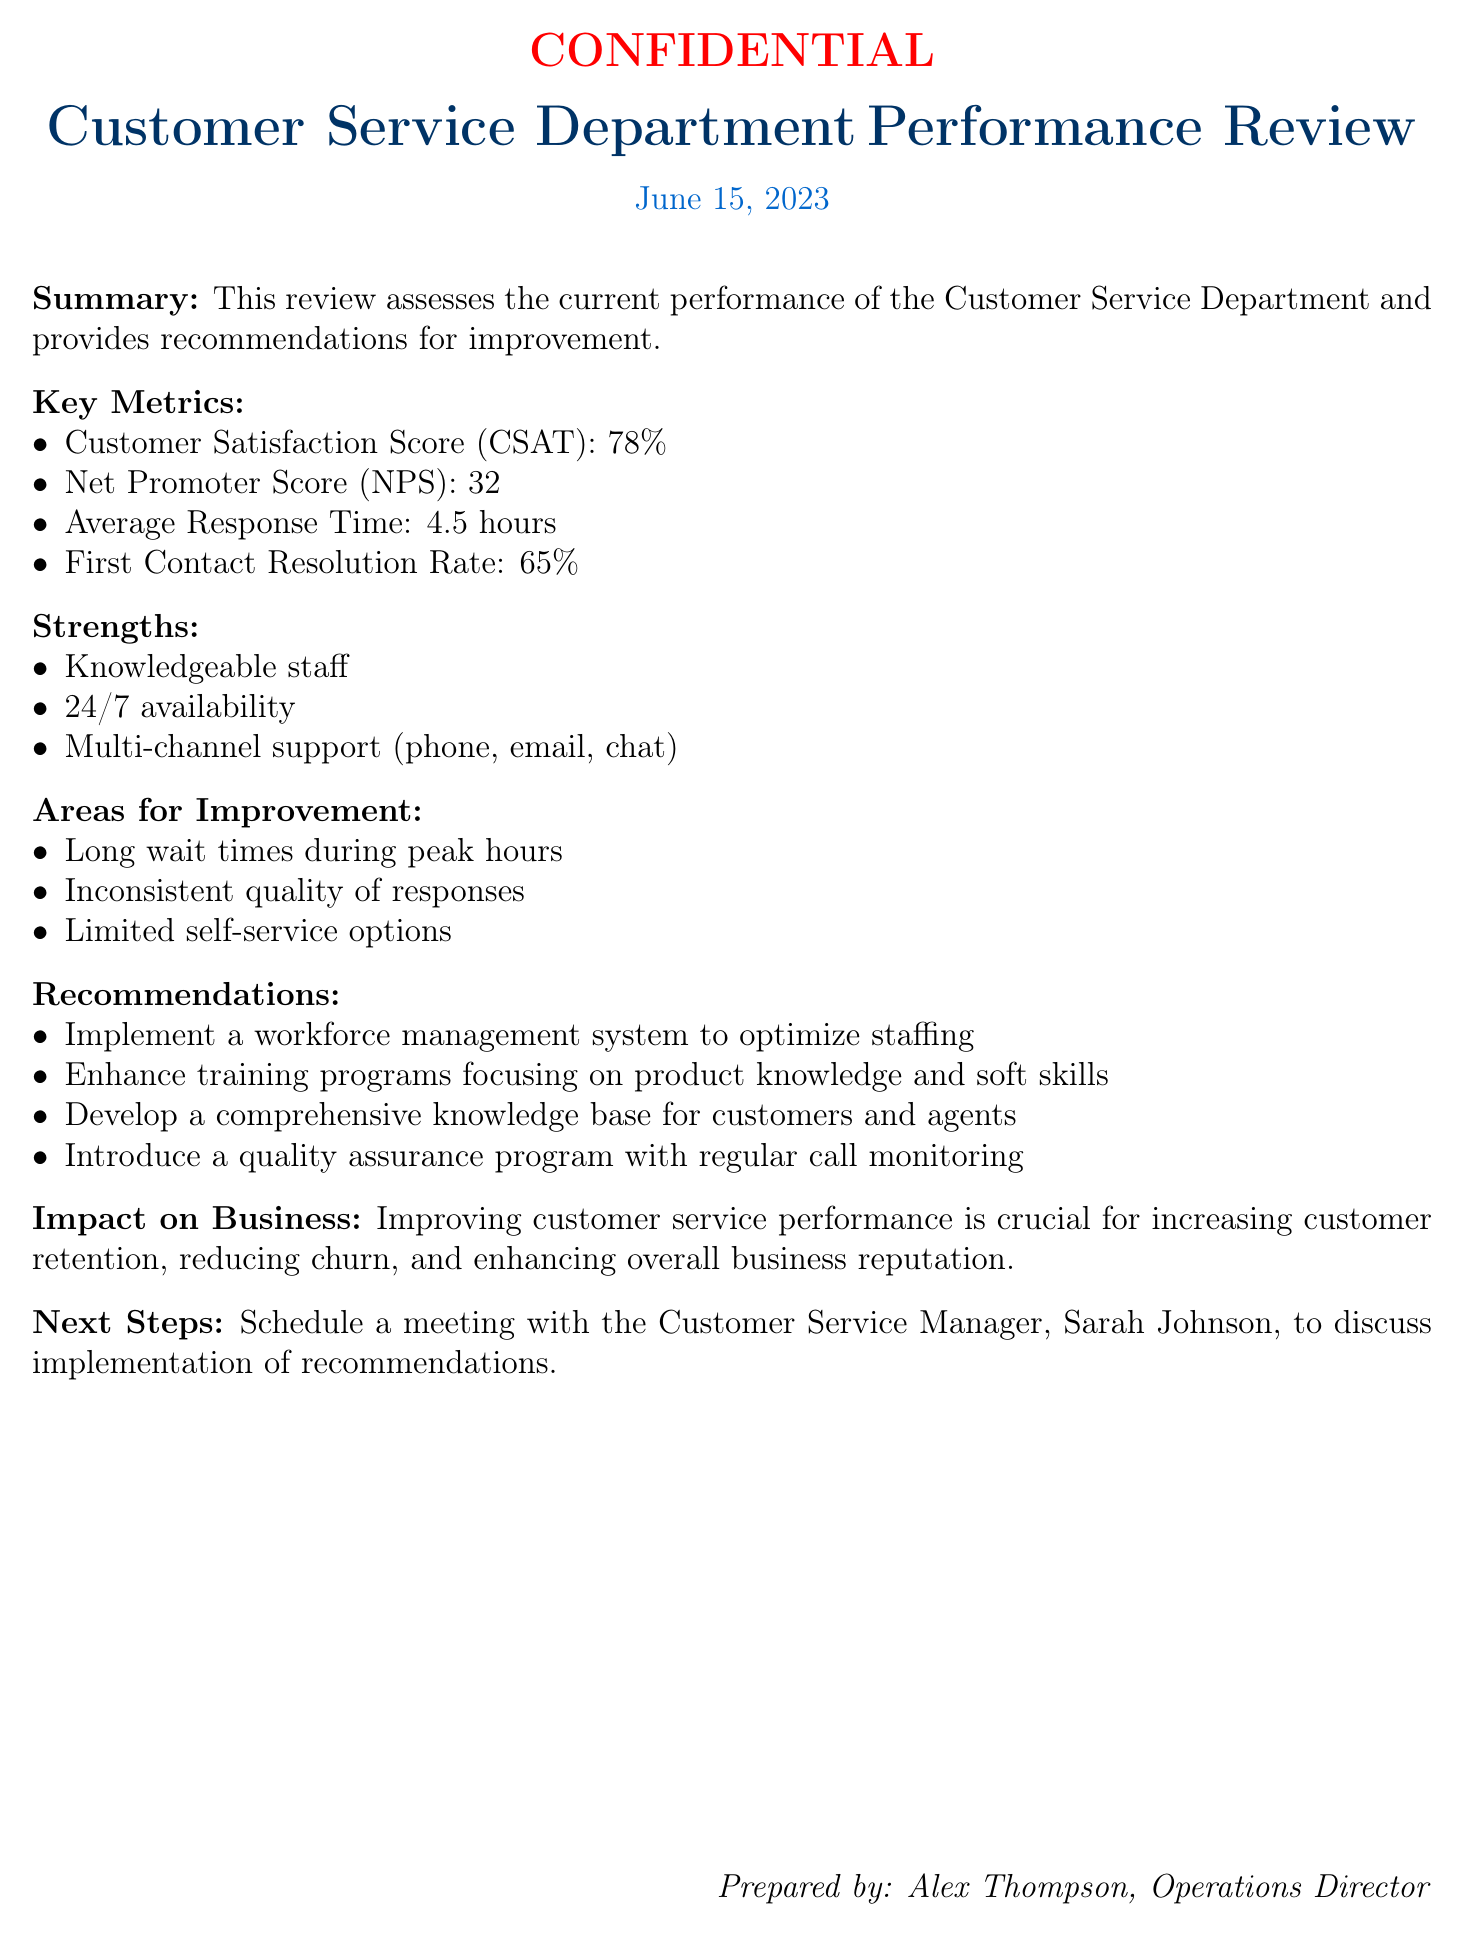What is the date of the performance review? The date at the top of the document states it was conducted on June 15, 2023.
Answer: June 15, 2023 What is the Customer Satisfaction Score (CSAT)? The Customer Satisfaction Score (CSAT) is noted as 78% in the key metrics section.
Answer: 78% What is one of the strengths of the Customer Service Department? The strengths listed include knowledgeable staff, among others, in the strengths section.
Answer: Knowledgeable staff What is the First Contact Resolution Rate? The First Contact Resolution Rate is mentioned as 65% in the key metrics section.
Answer: 65% What recommendation is made regarding training programs? The document suggests enhancing training programs focusing on product knowledge and soft skills under recommendations.
Answer: Enhance training programs What is a noted area for improvement? The areas for improvement section mentions long wait times during peak hours as one of the issues.
Answer: Long wait times during peak hours Who prepared this performance review? The document indicates that Alex Thompson is the one who prepared it, as seen at the bottom.
Answer: Alex Thompson What is the impact of improving customer service performance? The impact on business section states that it is crucial for increasing customer retention, reducing churn, and enhancing overall business reputation.
Answer: Increasing customer retention How often should call monitoring occur according to the recommendations? The document indicates introducing a quality assurance program with regular call monitoring under recommendations.
Answer: Regular 